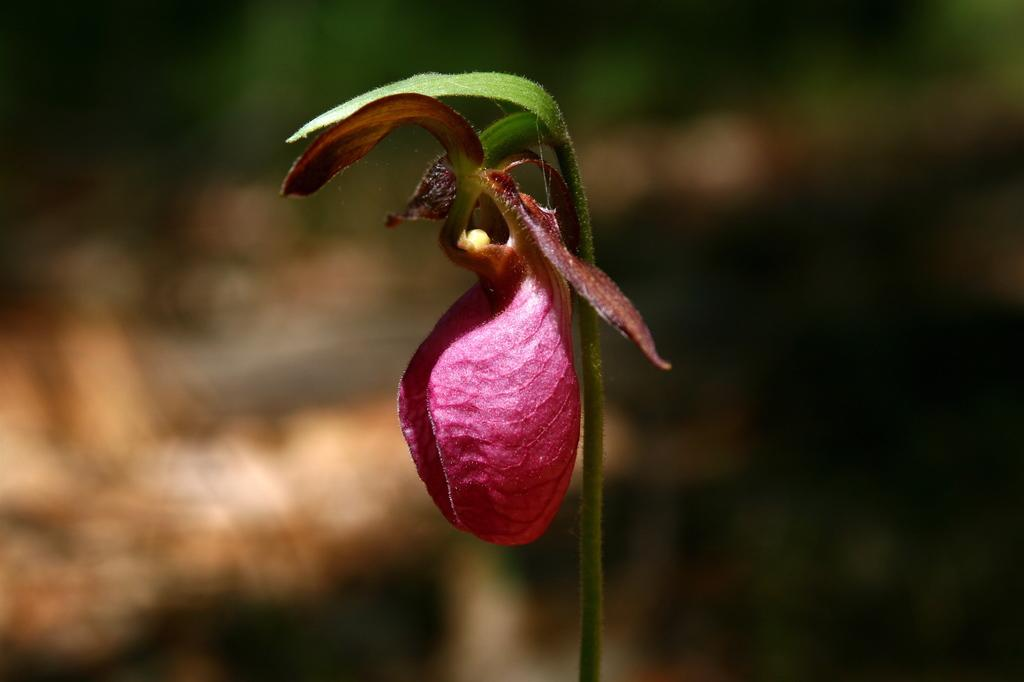What is present in the image? There is a plant in the image. What can be observed about the plant? The plant has a flower. What color is the flower? The flower is pink. What is the background of the image? The background of the image is black and blurred. Where is the group of people located in the image? There is no group of people present in the image; it features a plant with a pink flower against a black, blurred background. 